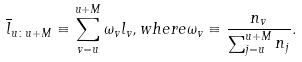Convert formula to latex. <formula><loc_0><loc_0><loc_500><loc_500>\overline { l } _ { u \colon u + M } \equiv \sum _ { v = u } ^ { u + M } \omega _ { v } l _ { v } , w h e r e \omega _ { v } \equiv \frac { n _ { v } } { \sum _ { j = u } ^ { u + M } n _ { j } } .</formula> 